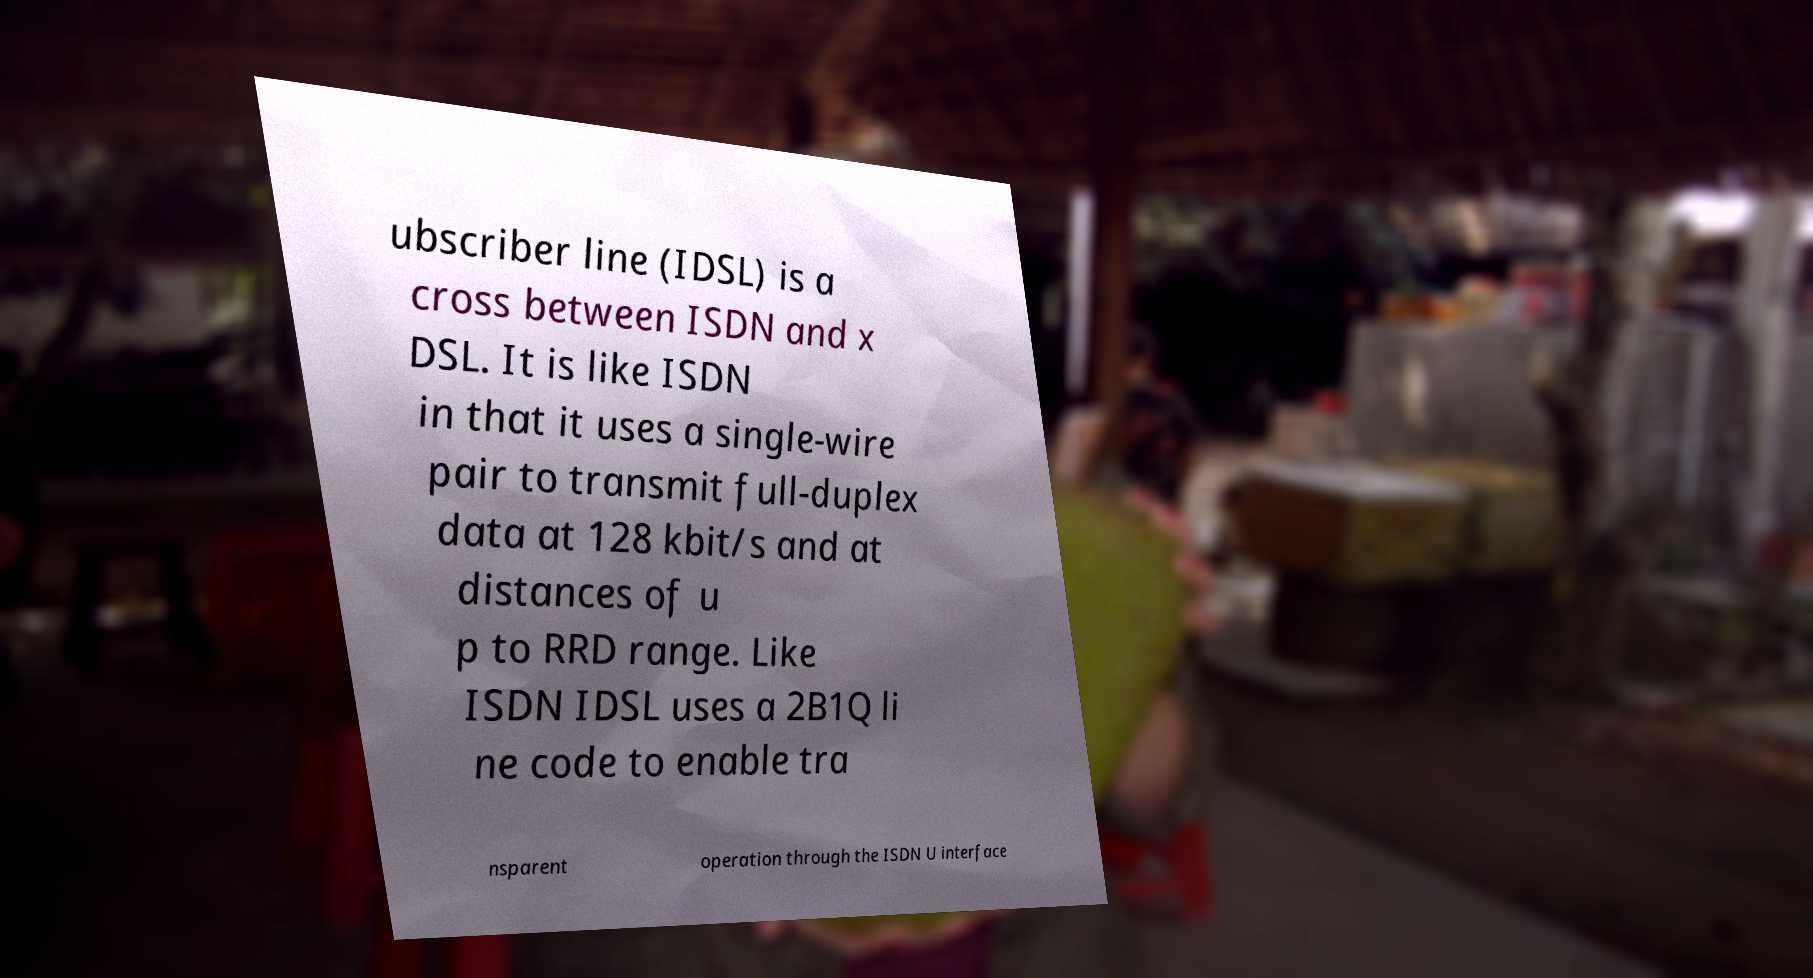Please identify and transcribe the text found in this image. ubscriber line (IDSL) is a cross between ISDN and x DSL. It is like ISDN in that it uses a single-wire pair to transmit full-duplex data at 128 kbit/s and at distances of u p to RRD range. Like ISDN IDSL uses a 2B1Q li ne code to enable tra nsparent operation through the ISDN U interface 